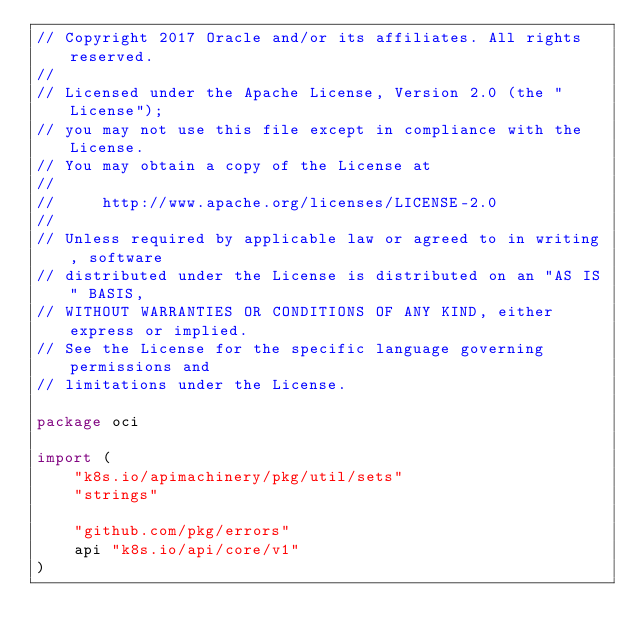<code> <loc_0><loc_0><loc_500><loc_500><_Go_>// Copyright 2017 Oracle and/or its affiliates. All rights reserved.
//
// Licensed under the Apache License, Version 2.0 (the "License");
// you may not use this file except in compliance with the License.
// You may obtain a copy of the License at
//
//     http://www.apache.org/licenses/LICENSE-2.0
//
// Unless required by applicable law or agreed to in writing, software
// distributed under the License is distributed on an "AS IS" BASIS,
// WITHOUT WARRANTIES OR CONDITIONS OF ANY KIND, either express or implied.
// See the License for the specific language governing permissions and
// limitations under the License.

package oci

import (
	"k8s.io/apimachinery/pkg/util/sets"
	"strings"

	"github.com/pkg/errors"
	api "k8s.io/api/core/v1"
)
</code> 